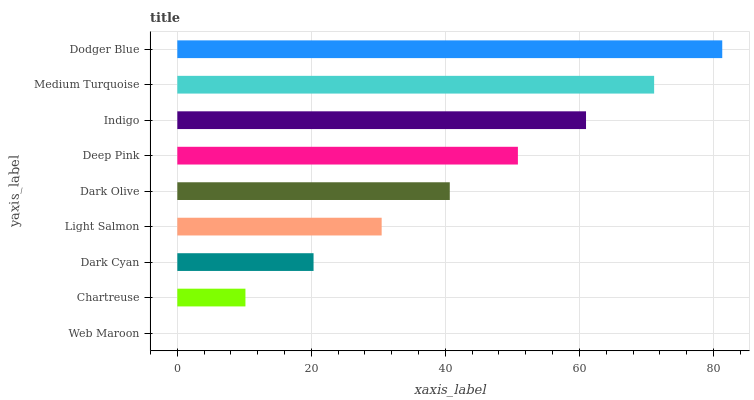Is Web Maroon the minimum?
Answer yes or no. Yes. Is Dodger Blue the maximum?
Answer yes or no. Yes. Is Chartreuse the minimum?
Answer yes or no. No. Is Chartreuse the maximum?
Answer yes or no. No. Is Chartreuse greater than Web Maroon?
Answer yes or no. Yes. Is Web Maroon less than Chartreuse?
Answer yes or no. Yes. Is Web Maroon greater than Chartreuse?
Answer yes or no. No. Is Chartreuse less than Web Maroon?
Answer yes or no. No. Is Dark Olive the high median?
Answer yes or no. Yes. Is Dark Olive the low median?
Answer yes or no. Yes. Is Light Salmon the high median?
Answer yes or no. No. Is Deep Pink the low median?
Answer yes or no. No. 